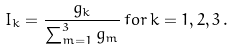<formula> <loc_0><loc_0><loc_500><loc_500>I _ { k } = \frac { g _ { k } } { \sum _ { m = 1 } ^ { 3 } g _ { m } } \, f o r \, k = 1 , 2 , 3 \, .</formula> 